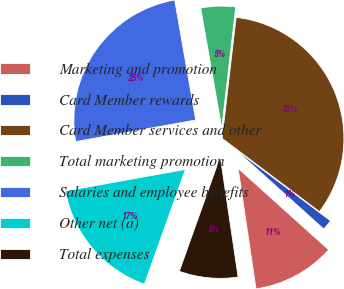Convert chart to OTSL. <chart><loc_0><loc_0><loc_500><loc_500><pie_chart><fcel>Marketing and promotion<fcel>Card Member rewards<fcel>Card Member services and other<fcel>Total marketing promotion<fcel>Salaries and employee benefits<fcel>Other net (a)<fcel>Total expenses<nl><fcel>11.0%<fcel>1.39%<fcel>33.43%<fcel>4.6%<fcel>25.07%<fcel>16.71%<fcel>7.8%<nl></chart> 